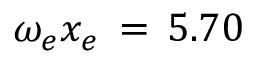<formula> <loc_0><loc_0><loc_500><loc_500>\omega _ { e } x _ { e } \, = \, 5 . 7 0</formula> 